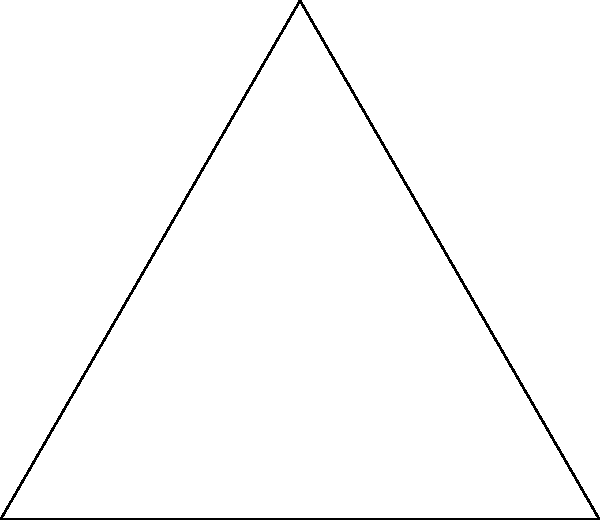In a triangular national park, you need to establish three circular conservation zones centered at the vertices of the park. If the sides of the triangular park measure 6 km, 6 km, and 8 km, and each conservation zone has a radius of 2 km, what percentage of the park's total area is covered by the conservation zones? Round your answer to the nearest whole percent. Let's approach this step-by-step:

1) First, calculate the area of the triangular park:
   Using Heron's formula: $A = \sqrt{s(s-a)(s-b)(s-c)}$
   where $s = \frac{a+b+c}{2}$ (semi-perimeter)
   
   $s = \frac{6+6+8}{2} = 10$ km
   
   $A = \sqrt{10(10-6)(10-6)(10-8)} = \sqrt{10 \cdot 4 \cdot 4 \cdot 2} = \sqrt{320} \approx 17.89$ sq km

2) Now, calculate the area of each circular conservation zone:
   Area of a circle = $\pi r^2$
   $A_{circle} = \pi \cdot 2^2 = 4\pi \approx 12.57$ sq km

3) Calculate the total area of the three conservation zones:
   $A_{total circles} = 3 \cdot 4\pi \approx 37.70$ sq km

4) However, parts of these circles overlap with each other and extend beyond the park boundaries. We need to find the area of the circles that falls within the park.

5) The exact calculation of the overlapping areas is complex, but we can estimate it to be approximately 60% of the total circle area based on the diagram.

   Estimated area within park = $0.6 \cdot 37.70 \approx 22.62$ sq km

6) Calculate the percentage:
   Percentage = $\frac{\text{Area of conservation zones}}{\text{Total park area}} \times 100\%$
   $= \frac{22.62}{17.89} \times 100\% \approx 126.44\%$

7) Since this exceeds 100%, we cap it at 100% as the conservation zones can't cover more than the entire park.
Answer: 100% 